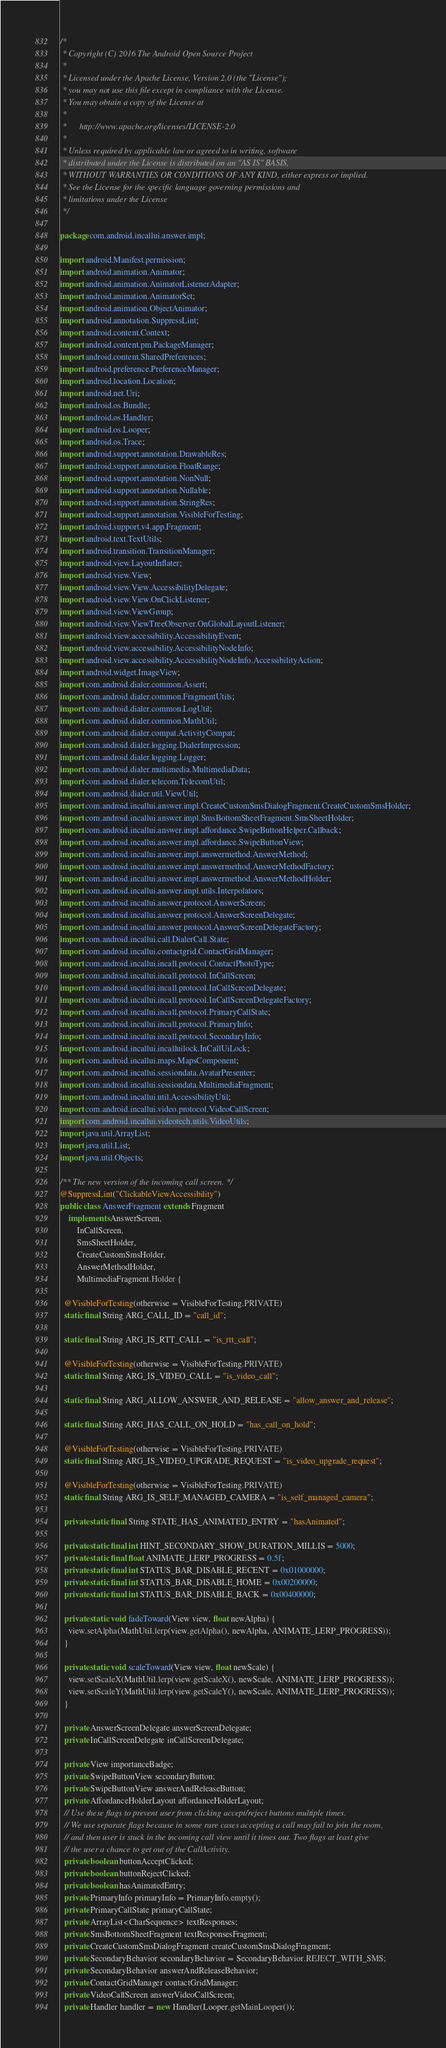<code> <loc_0><loc_0><loc_500><loc_500><_Java_>/*
 * Copyright (C) 2016 The Android Open Source Project
 *
 * Licensed under the Apache License, Version 2.0 (the "License");
 * you may not use this file except in compliance with the License.
 * You may obtain a copy of the License at
 *
 *      http://www.apache.org/licenses/LICENSE-2.0
 *
 * Unless required by applicable law or agreed to in writing, software
 * distributed under the License is distributed on an "AS IS" BASIS,
 * WITHOUT WARRANTIES OR CONDITIONS OF ANY KIND, either express or implied.
 * See the License for the specific language governing permissions and
 * limitations under the License
 */

package com.android.incallui.answer.impl;

import android.Manifest.permission;
import android.animation.Animator;
import android.animation.AnimatorListenerAdapter;
import android.animation.AnimatorSet;
import android.animation.ObjectAnimator;
import android.annotation.SuppressLint;
import android.content.Context;
import android.content.pm.PackageManager;
import android.content.SharedPreferences;
import android.preference.PreferenceManager;
import android.location.Location;
import android.net.Uri;
import android.os.Bundle;
import android.os.Handler;
import android.os.Looper;
import android.os.Trace;
import android.support.annotation.DrawableRes;
import android.support.annotation.FloatRange;
import android.support.annotation.NonNull;
import android.support.annotation.Nullable;
import android.support.annotation.StringRes;
import android.support.annotation.VisibleForTesting;
import android.support.v4.app.Fragment;
import android.text.TextUtils;
import android.transition.TransitionManager;
import android.view.LayoutInflater;
import android.view.View;
import android.view.View.AccessibilityDelegate;
import android.view.View.OnClickListener;
import android.view.ViewGroup;
import android.view.ViewTreeObserver.OnGlobalLayoutListener;
import android.view.accessibility.AccessibilityEvent;
import android.view.accessibility.AccessibilityNodeInfo;
import android.view.accessibility.AccessibilityNodeInfo.AccessibilityAction;
import android.widget.ImageView;
import com.android.dialer.common.Assert;
import com.android.dialer.common.FragmentUtils;
import com.android.dialer.common.LogUtil;
import com.android.dialer.common.MathUtil;
import com.android.dialer.compat.ActivityCompat;
import com.android.dialer.logging.DialerImpression;
import com.android.dialer.logging.Logger;
import com.android.dialer.multimedia.MultimediaData;
import com.android.dialer.telecom.TelecomUtil;
import com.android.dialer.util.ViewUtil;
import com.android.incallui.answer.impl.CreateCustomSmsDialogFragment.CreateCustomSmsHolder;
import com.android.incallui.answer.impl.SmsBottomSheetFragment.SmsSheetHolder;
import com.android.incallui.answer.impl.affordance.SwipeButtonHelper.Callback;
import com.android.incallui.answer.impl.affordance.SwipeButtonView;
import com.android.incallui.answer.impl.answermethod.AnswerMethod;
import com.android.incallui.answer.impl.answermethod.AnswerMethodFactory;
import com.android.incallui.answer.impl.answermethod.AnswerMethodHolder;
import com.android.incallui.answer.impl.utils.Interpolators;
import com.android.incallui.answer.protocol.AnswerScreen;
import com.android.incallui.answer.protocol.AnswerScreenDelegate;
import com.android.incallui.answer.protocol.AnswerScreenDelegateFactory;
import com.android.incallui.call.DialerCall.State;
import com.android.incallui.contactgrid.ContactGridManager;
import com.android.incallui.incall.protocol.ContactPhotoType;
import com.android.incallui.incall.protocol.InCallScreen;
import com.android.incallui.incall.protocol.InCallScreenDelegate;
import com.android.incallui.incall.protocol.InCallScreenDelegateFactory;
import com.android.incallui.incall.protocol.PrimaryCallState;
import com.android.incallui.incall.protocol.PrimaryInfo;
import com.android.incallui.incall.protocol.SecondaryInfo;
import com.android.incallui.incalluilock.InCallUiLock;
import com.android.incallui.maps.MapsComponent;
import com.android.incallui.sessiondata.AvatarPresenter;
import com.android.incallui.sessiondata.MultimediaFragment;
import com.android.incallui.util.AccessibilityUtil;
import com.android.incallui.video.protocol.VideoCallScreen;
import com.android.incallui.videotech.utils.VideoUtils;
import java.util.ArrayList;
import java.util.List;
import java.util.Objects;

/** The new version of the incoming call screen. */
@SuppressLint("ClickableViewAccessibility")
public class AnswerFragment extends Fragment
    implements AnswerScreen,
        InCallScreen,
        SmsSheetHolder,
        CreateCustomSmsHolder,
        AnswerMethodHolder,
        MultimediaFragment.Holder {

  @VisibleForTesting(otherwise = VisibleForTesting.PRIVATE)
  static final String ARG_CALL_ID = "call_id";

  static final String ARG_IS_RTT_CALL = "is_rtt_call";

  @VisibleForTesting(otherwise = VisibleForTesting.PRIVATE)
  static final String ARG_IS_VIDEO_CALL = "is_video_call";

  static final String ARG_ALLOW_ANSWER_AND_RELEASE = "allow_answer_and_release";

  static final String ARG_HAS_CALL_ON_HOLD = "has_call_on_hold";

  @VisibleForTesting(otherwise = VisibleForTesting.PRIVATE)
  static final String ARG_IS_VIDEO_UPGRADE_REQUEST = "is_video_upgrade_request";

  @VisibleForTesting(otherwise = VisibleForTesting.PRIVATE)
  static final String ARG_IS_SELF_MANAGED_CAMERA = "is_self_managed_camera";

  private static final String STATE_HAS_ANIMATED_ENTRY = "hasAnimated";

  private static final int HINT_SECONDARY_SHOW_DURATION_MILLIS = 5000;
  private static final float ANIMATE_LERP_PROGRESS = 0.5f;
  private static final int STATUS_BAR_DISABLE_RECENT = 0x01000000;
  private static final int STATUS_BAR_DISABLE_HOME = 0x00200000;
  private static final int STATUS_BAR_DISABLE_BACK = 0x00400000;

  private static void fadeToward(View view, float newAlpha) {
    view.setAlpha(MathUtil.lerp(view.getAlpha(), newAlpha, ANIMATE_LERP_PROGRESS));
  }

  private static void scaleToward(View view, float newScale) {
    view.setScaleX(MathUtil.lerp(view.getScaleX(), newScale, ANIMATE_LERP_PROGRESS));
    view.setScaleY(MathUtil.lerp(view.getScaleY(), newScale, ANIMATE_LERP_PROGRESS));
  }

  private AnswerScreenDelegate answerScreenDelegate;
  private InCallScreenDelegate inCallScreenDelegate;

  private View importanceBadge;
  private SwipeButtonView secondaryButton;
  private SwipeButtonView answerAndReleaseButton;
  private AffordanceHolderLayout affordanceHolderLayout;
  // Use these flags to prevent user from clicking accept/reject buttons multiple times.
  // We use separate flags because in some rare cases accepting a call may fail to join the room,
  // and then user is stuck in the incoming call view until it times out. Two flags at least give
  // the user a chance to get out of the CallActivity.
  private boolean buttonAcceptClicked;
  private boolean buttonRejectClicked;
  private boolean hasAnimatedEntry;
  private PrimaryInfo primaryInfo = PrimaryInfo.empty();
  private PrimaryCallState primaryCallState;
  private ArrayList<CharSequence> textResponses;
  private SmsBottomSheetFragment textResponsesFragment;
  private CreateCustomSmsDialogFragment createCustomSmsDialogFragment;
  private SecondaryBehavior secondaryBehavior = SecondaryBehavior.REJECT_WITH_SMS;
  private SecondaryBehavior answerAndReleaseBehavior;
  private ContactGridManager contactGridManager;
  private VideoCallScreen answerVideoCallScreen;
  private Handler handler = new Handler(Looper.getMainLooper());</code> 